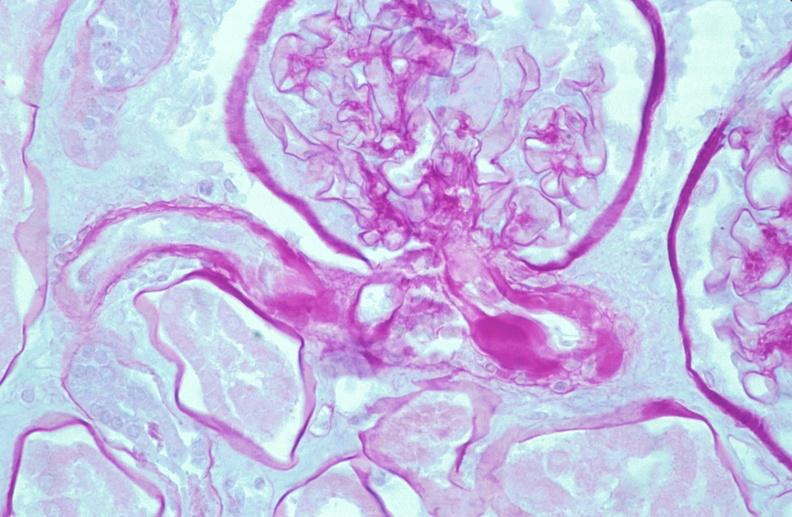why does this image show kidney, thickened and hyalinized basement membranes?
Answer the question using a single word or phrase. Due to diabetes mellitus pas 